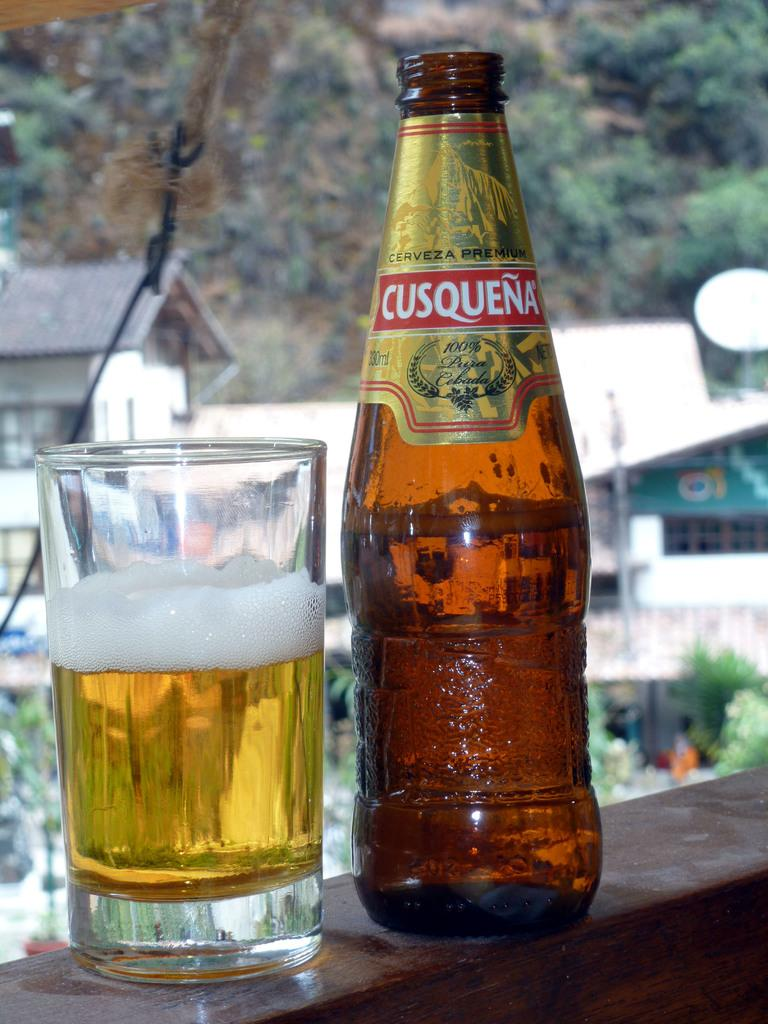<image>
Render a clear and concise summary of the photo. A bottle of Cusquena Cerveza Premium sits next to a half full pint glass. 